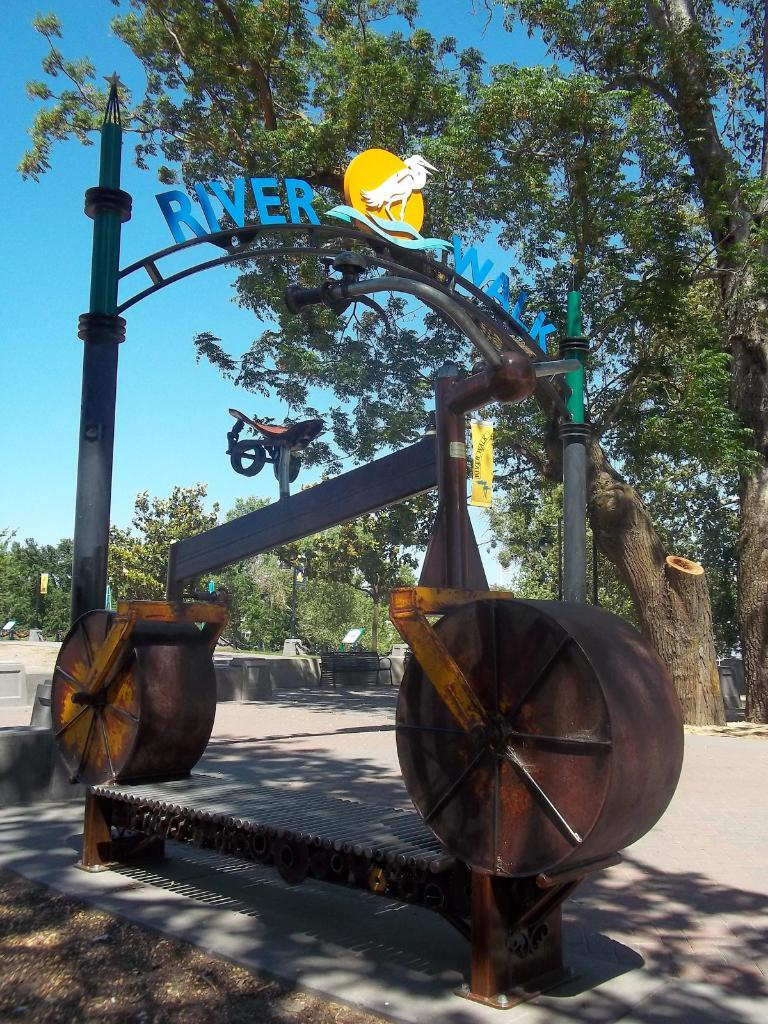What is the main subject of the image? The main subject of the image is a bicycle made with iron scraps. Where is the bicycle located in the image? The bicycle is on a path in the image. What can be seen in the background of the image? In the background of the image, there are larch trees, other trees, boards, a bench, and the sky. How many sisters are present in the image? There are no sisters present in the image; it features a bicycle made with iron scraps and various elements in the background. 